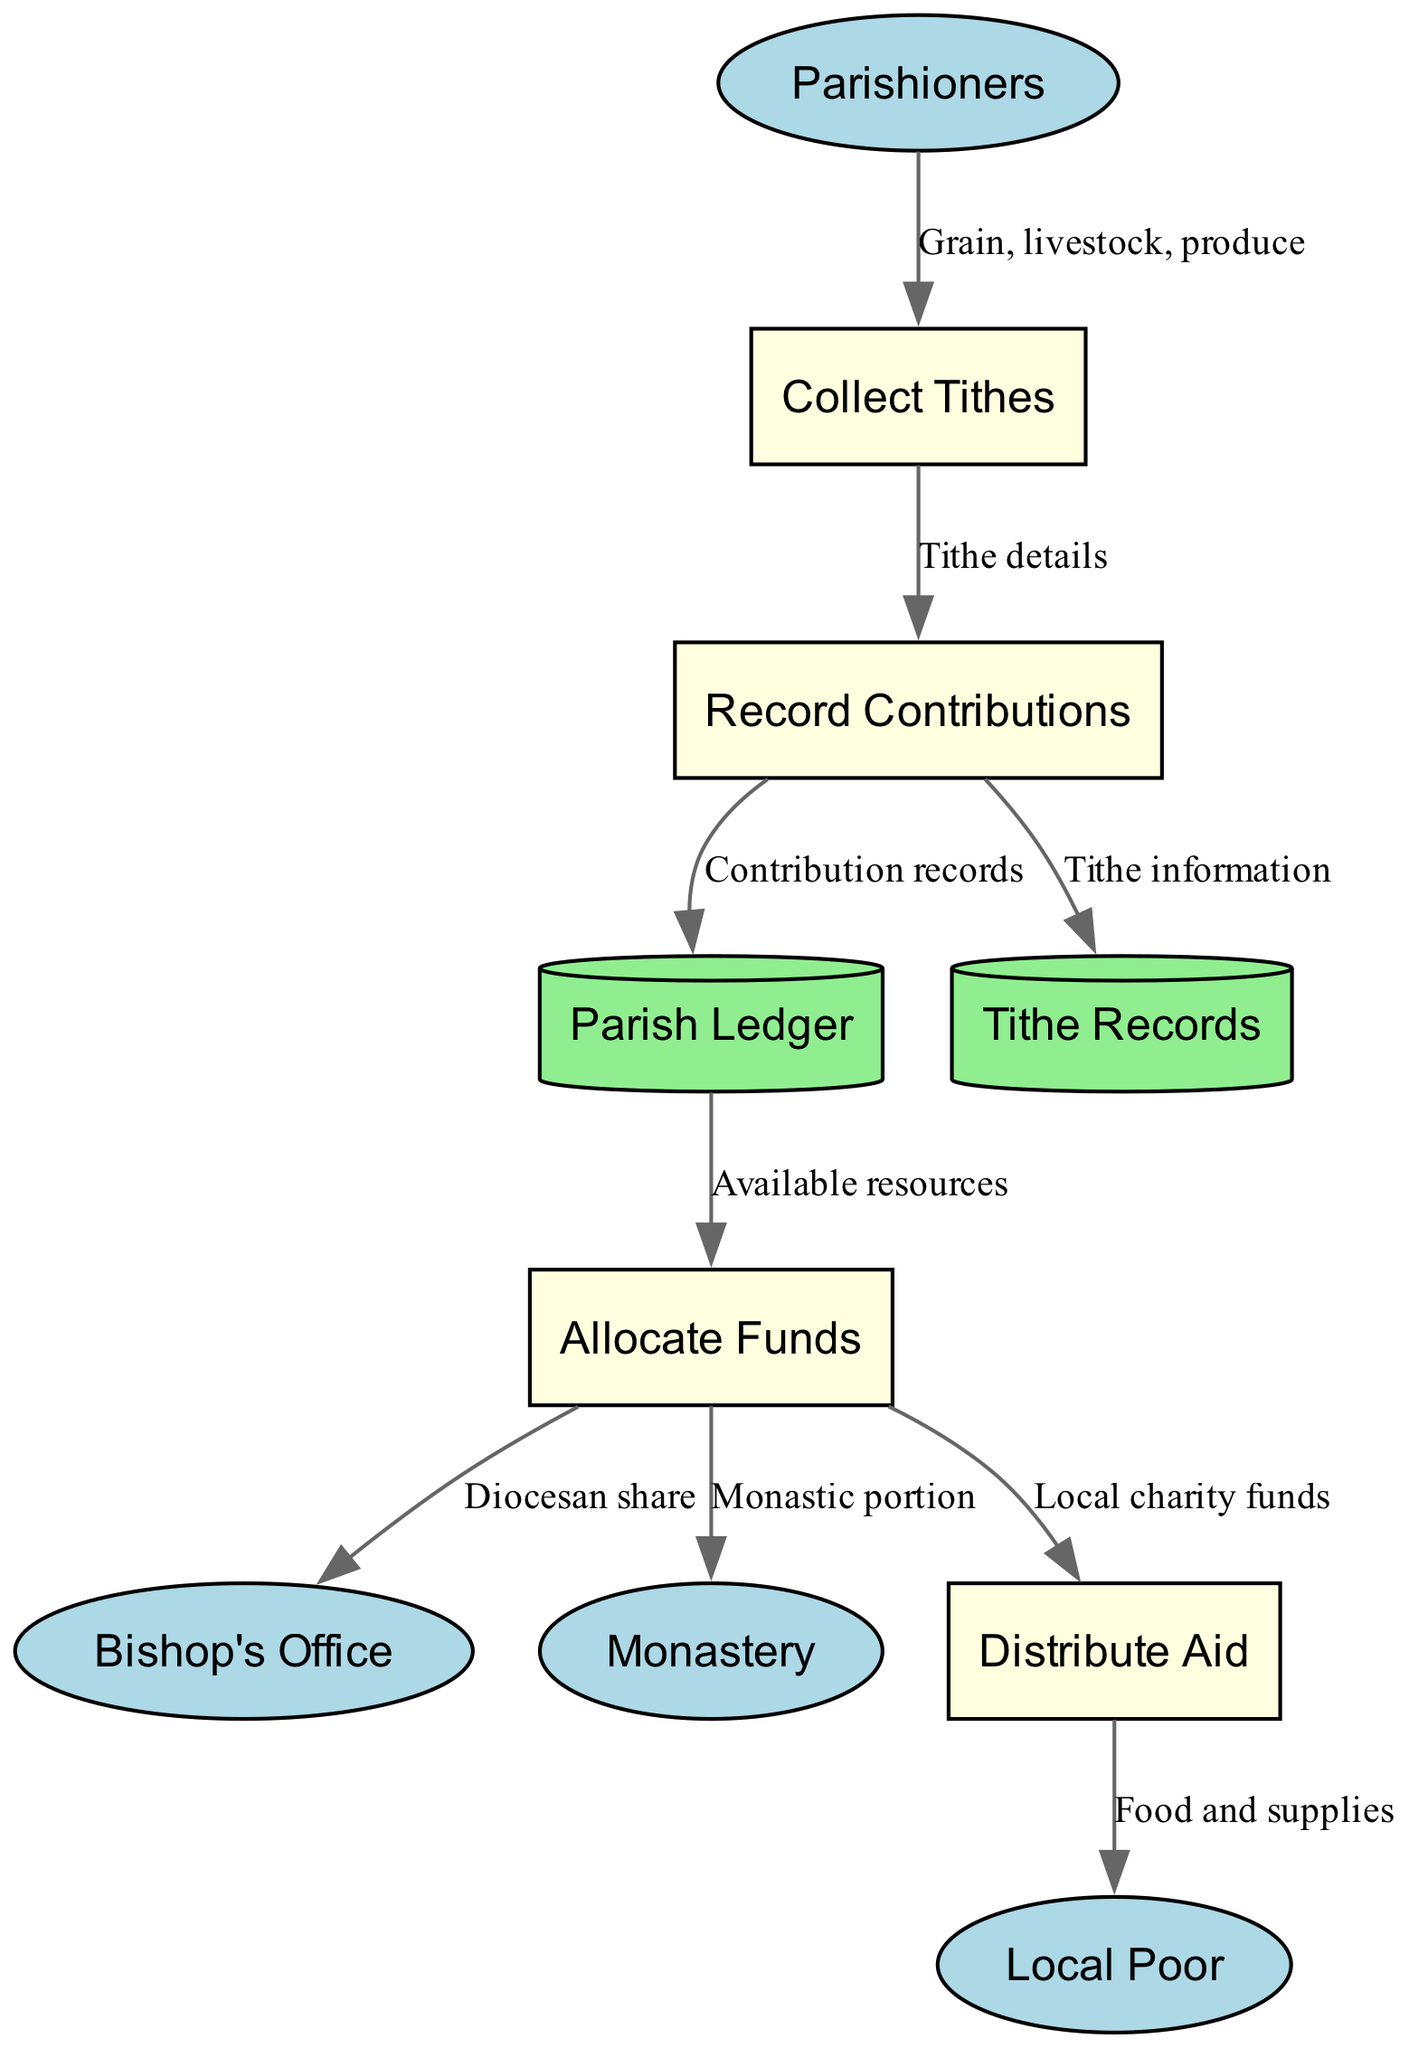What are the external entities in this diagram? The external entities can be found in the outer part of the diagram. They include Parishioners, Bishop's Office, Monastery, and Local Poor.
Answer: Parishioners, Bishop's Office, Monastery, Local Poor How many processes are represented in the diagram? The processes are found in the middle of the diagram and consist of Collect Tithes, Record Contributions, Allocate Funds, and Distribute Aid. There are four processes in total.
Answer: 4 Which process receives data directly from parishioners? Following the data flow, it can be seen that the data labeled "Grain, livestock, produce" flows from Parishioners to the Collect Tithes process. Hence, Collect Tithes is the process that receives data directly from parishioners.
Answer: Collect Tithes What is the main output of the Distribute Aid process? The Distribute Aid process outputs "Food and supplies" as indicated by the arrow pointing to Local Poor from Distribute Aid. This is the final result of the aid distribution.
Answer: Food and supplies Which data store receives contribution records? Contribution records flow into the Parish Ledger from the Record Contributions process, making the Parish Ledger the data store that receives these records.
Answer: Parish Ledger What data flows to the Bishop's Office from Allocate Funds? The data labeled "Diocesan share" is sent from the Allocate Funds process to the Bishop's Office, indicating what goes to the bishop.
Answer: Diocesan share How many data stores are present in the diagram? The diagram shows two data stores: Parish Ledger and Tithe Records. Therefore, the total number is two.
Answer: 2 Which entity is the final recipient of aid distributed in this diagram? Analyzing the distribution flow, the final recipient of aid as indicated in the diagram is the Local Poor, receiving food and supplies from the Distribute Aid process.
Answer: Local Poor What portion is allocated to the monastery from the funds? Funds designated for the monastery are labeled as "Monastic portion" and flow from Allocate Funds to the Monastery.
Answer: Monastic portion 